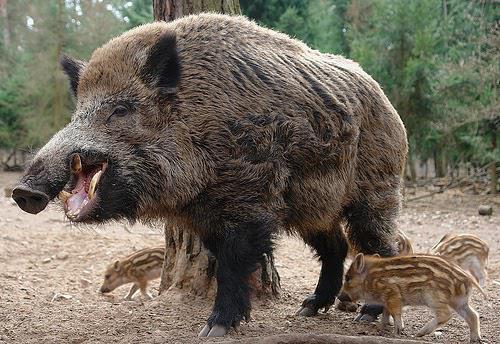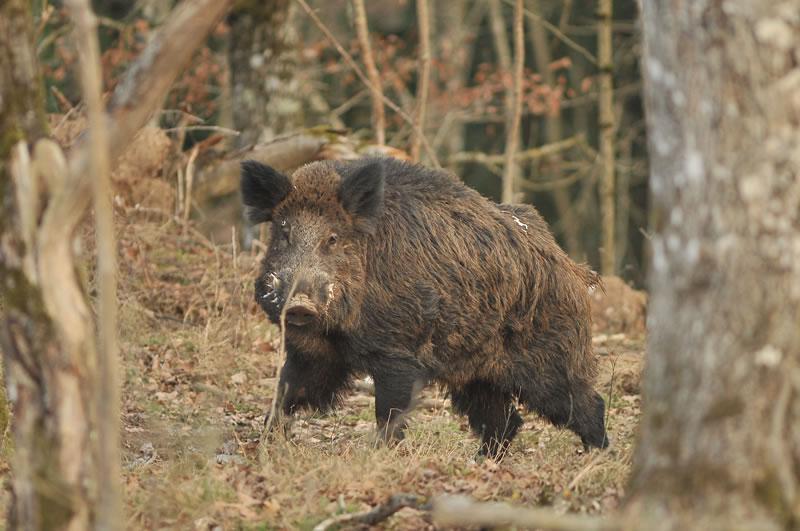The first image is the image on the left, the second image is the image on the right. Given the left and right images, does the statement "An image includes at least three striped baby pigs next to a standing adult wild hog." hold true? Answer yes or no. Yes. The first image is the image on the left, the second image is the image on the right. Considering the images on both sides, is "The left image contains at least four boars." valid? Answer yes or no. Yes. 